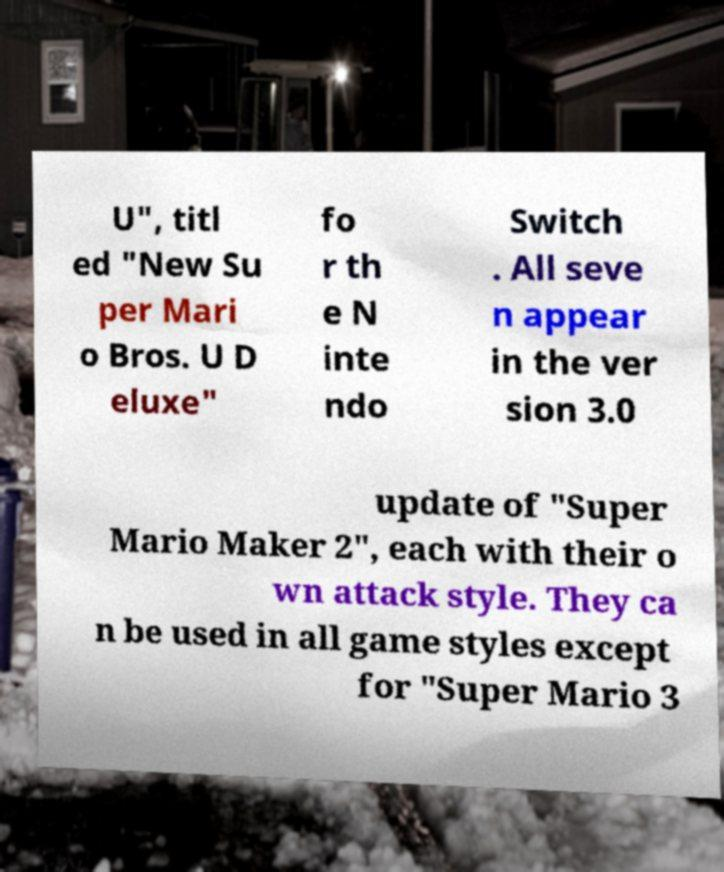I need the written content from this picture converted into text. Can you do that? U", titl ed "New Su per Mari o Bros. U D eluxe" fo r th e N inte ndo Switch . All seve n appear in the ver sion 3.0 update of "Super Mario Maker 2", each with their o wn attack style. They ca n be used in all game styles except for "Super Mario 3 